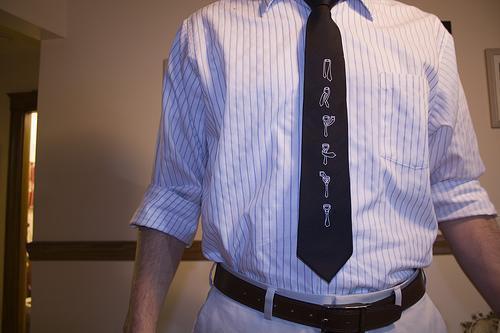How many people are there?
Give a very brief answer. 1. 